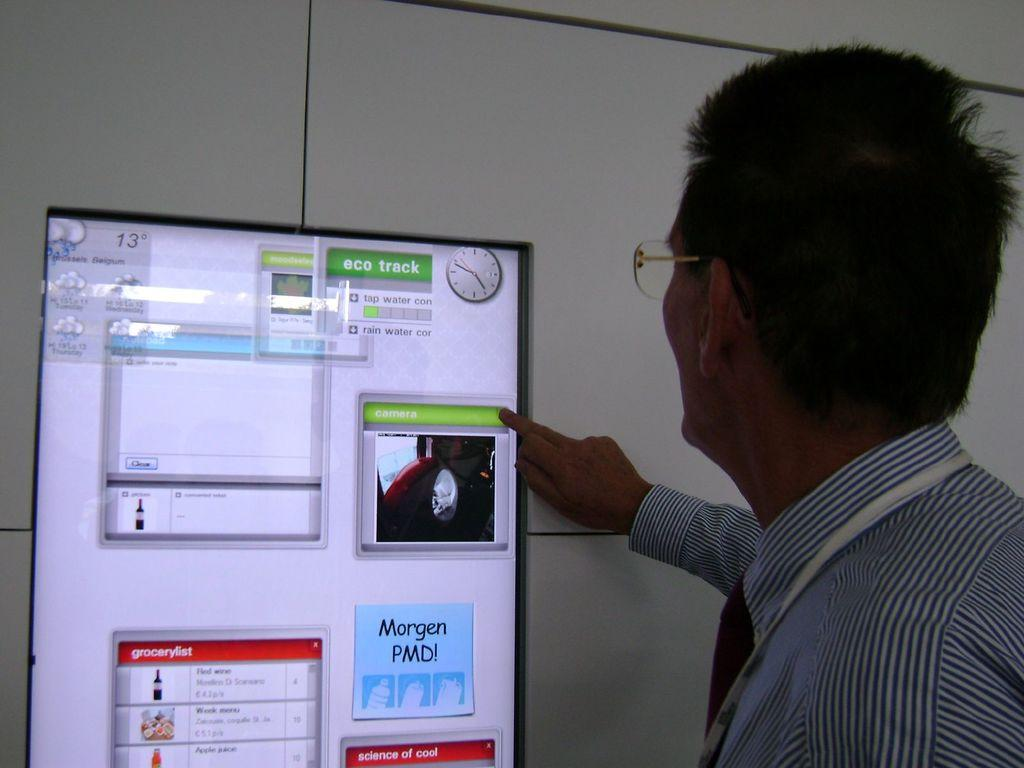What is the main subject of the image? There is a person in the image. What can be seen on the person's face? The person is wearing spectacles. What is the person doing in the image? The person is operating a monitor screen of a device. How is the person interacting with the device? The person's finger is on the screen. What can be seen in the background of the image? There is a wall visible in the background of the image. Can you see a drawer in the image? There is no drawer present in the image. Is the person wearing a mask in the image? The person is not wearing a mask in the image; they are wearing spectacles. 